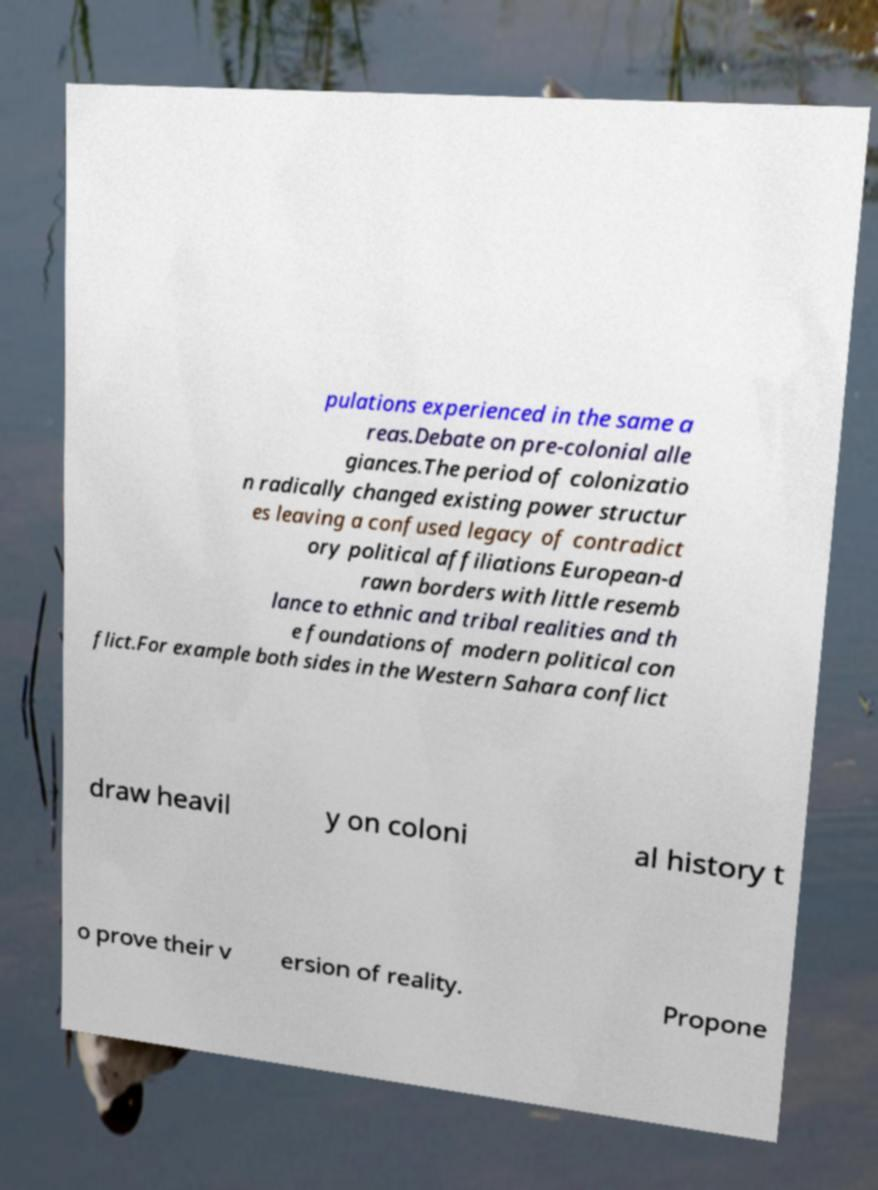There's text embedded in this image that I need extracted. Can you transcribe it verbatim? pulations experienced in the same a reas.Debate on pre-colonial alle giances.The period of colonizatio n radically changed existing power structur es leaving a confused legacy of contradict ory political affiliations European-d rawn borders with little resemb lance to ethnic and tribal realities and th e foundations of modern political con flict.For example both sides in the Western Sahara conflict draw heavil y on coloni al history t o prove their v ersion of reality. Propone 